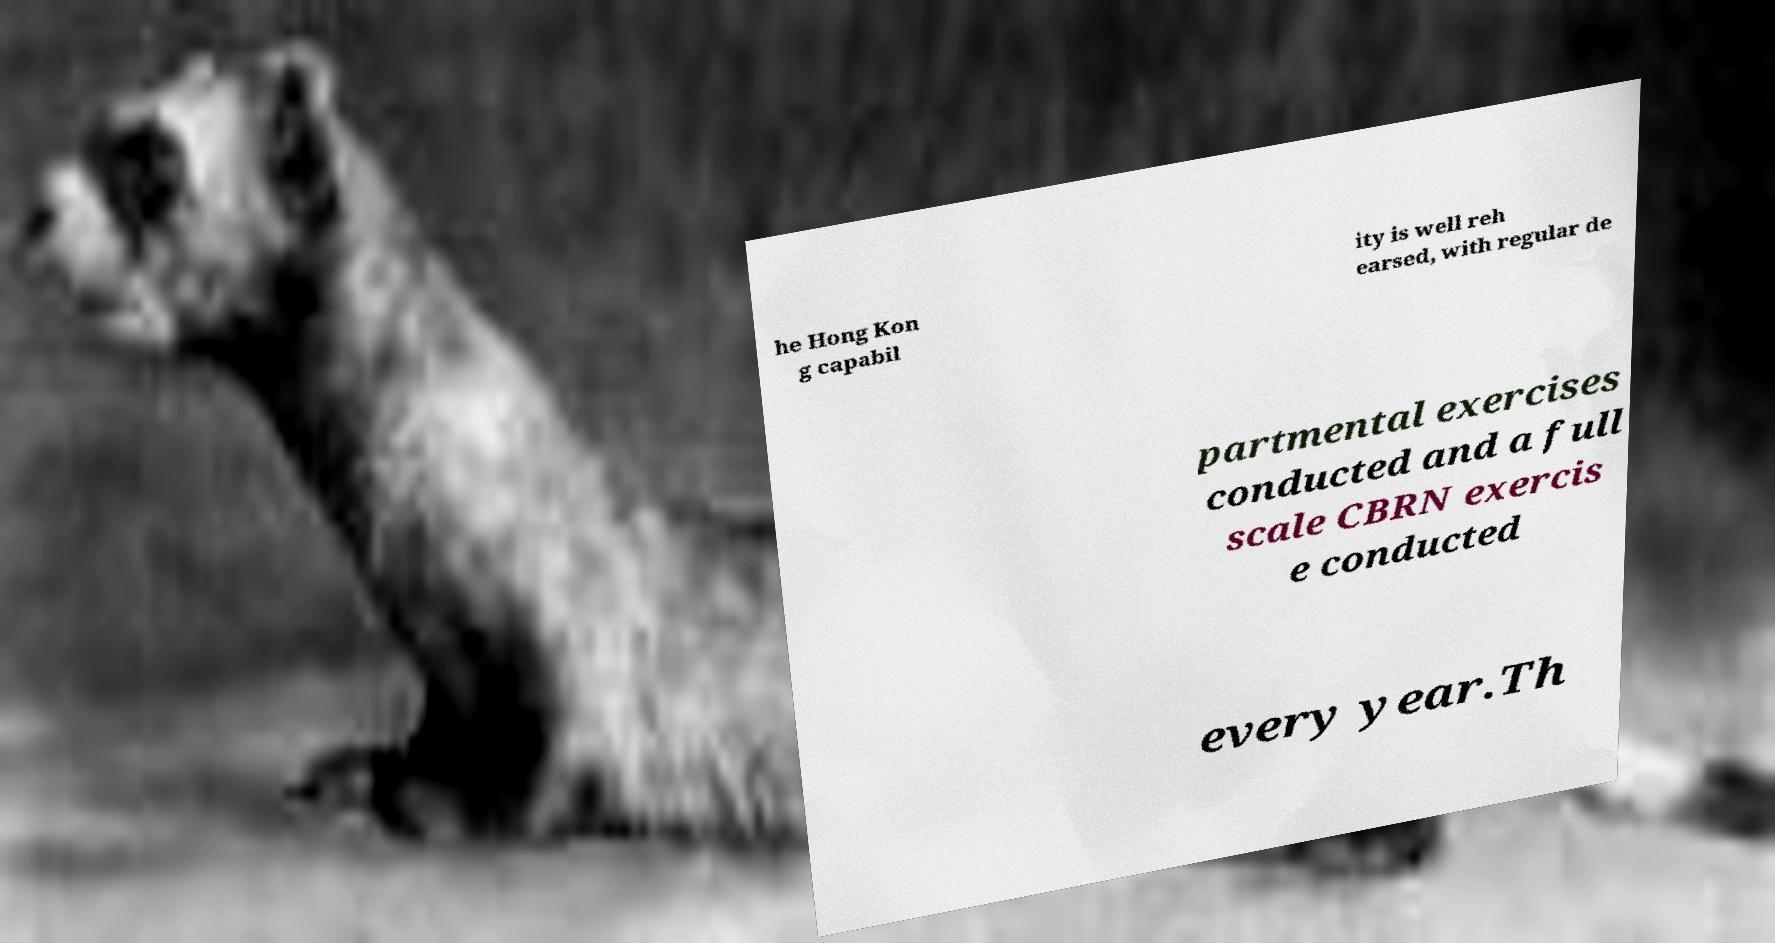Please identify and transcribe the text found in this image. he Hong Kon g capabil ity is well reh earsed, with regular de partmental exercises conducted and a full scale CBRN exercis e conducted every year.Th 